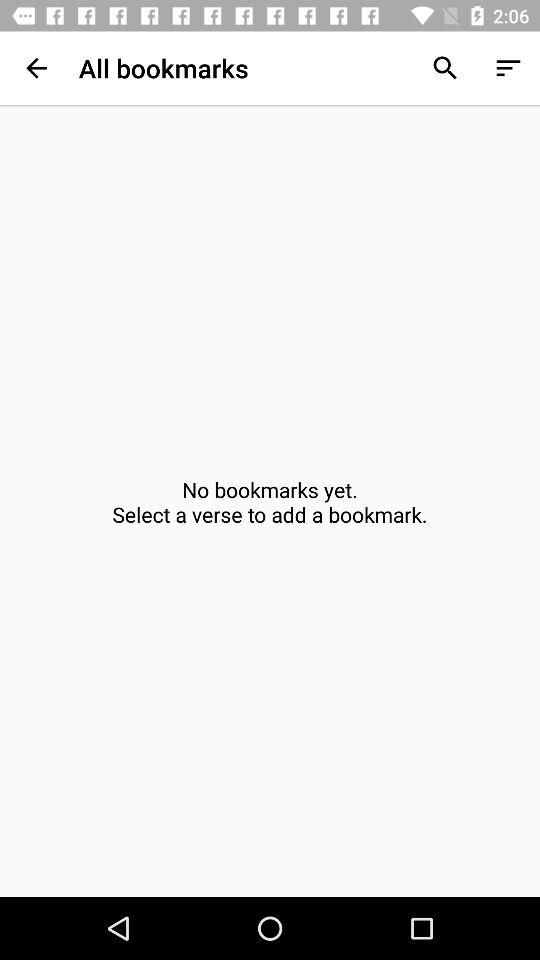Are there any bookmarks available? There are no bookmarks available. 